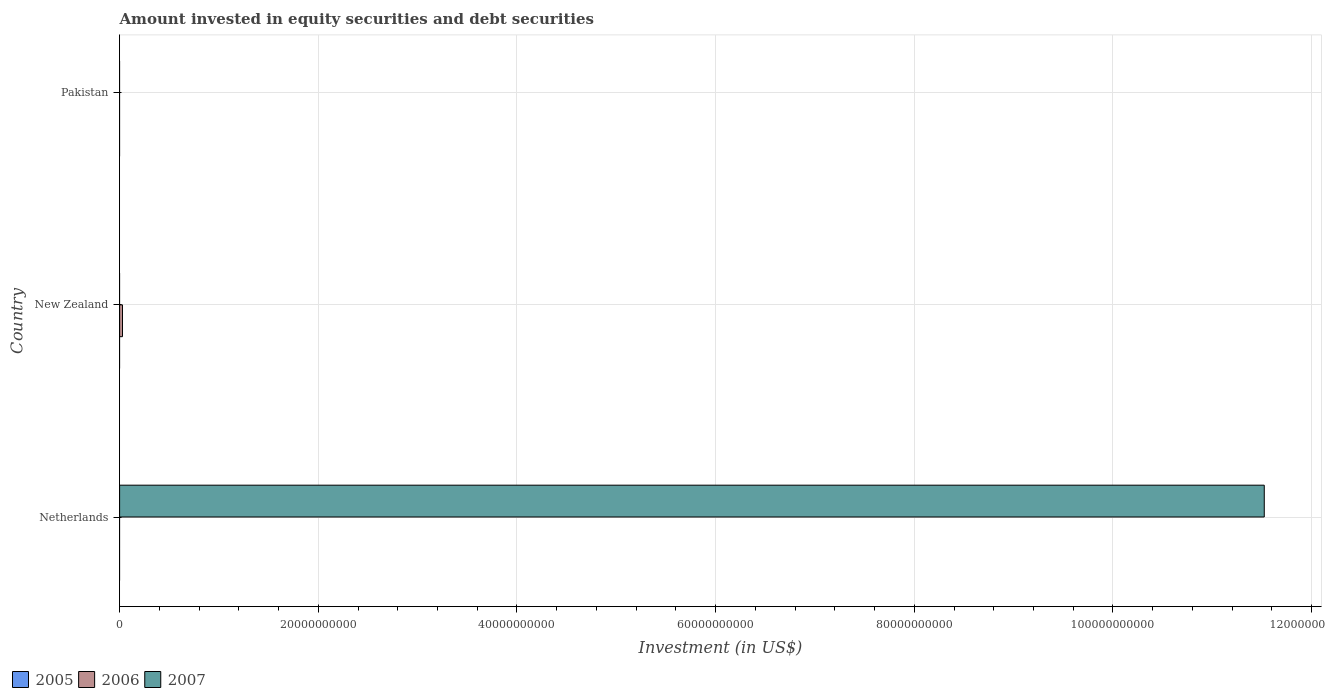Are the number of bars on each tick of the Y-axis equal?
Give a very brief answer. No. How many bars are there on the 2nd tick from the top?
Provide a succinct answer. 1. How many bars are there on the 3rd tick from the bottom?
Your answer should be compact. 0. In how many cases, is the number of bars for a given country not equal to the number of legend labels?
Keep it short and to the point. 3. Across all countries, what is the maximum amount invested in equity securities and debt securities in 2007?
Your answer should be compact. 1.15e+11. Across all countries, what is the minimum amount invested in equity securities and debt securities in 2006?
Ensure brevity in your answer.  0. What is the total amount invested in equity securities and debt securities in 2007 in the graph?
Your response must be concise. 1.15e+11. What is the difference between the amount invested in equity securities and debt securities in 2007 in Netherlands and the amount invested in equity securities and debt securities in 2006 in Pakistan?
Your answer should be compact. 1.15e+11. What is the average amount invested in equity securities and debt securities in 2007 per country?
Give a very brief answer. 3.84e+1. What is the difference between the highest and the lowest amount invested in equity securities and debt securities in 2006?
Your answer should be very brief. 2.91e+08. Is it the case that in every country, the sum of the amount invested in equity securities and debt securities in 2006 and amount invested in equity securities and debt securities in 2005 is greater than the amount invested in equity securities and debt securities in 2007?
Give a very brief answer. No. What is the difference between two consecutive major ticks on the X-axis?
Your response must be concise. 2.00e+1. Are the values on the major ticks of X-axis written in scientific E-notation?
Your answer should be compact. No. Does the graph contain any zero values?
Your answer should be very brief. Yes. Does the graph contain grids?
Provide a short and direct response. Yes. How many legend labels are there?
Provide a short and direct response. 3. What is the title of the graph?
Your answer should be compact. Amount invested in equity securities and debt securities. What is the label or title of the X-axis?
Your response must be concise. Investment (in US$). What is the label or title of the Y-axis?
Provide a succinct answer. Country. What is the Investment (in US$) in 2005 in Netherlands?
Your answer should be compact. 0. What is the Investment (in US$) in 2006 in Netherlands?
Provide a short and direct response. 0. What is the Investment (in US$) of 2007 in Netherlands?
Your answer should be very brief. 1.15e+11. What is the Investment (in US$) in 2006 in New Zealand?
Make the answer very short. 2.91e+08. What is the Investment (in US$) of 2005 in Pakistan?
Keep it short and to the point. 0. Across all countries, what is the maximum Investment (in US$) in 2006?
Your answer should be compact. 2.91e+08. Across all countries, what is the maximum Investment (in US$) in 2007?
Your response must be concise. 1.15e+11. What is the total Investment (in US$) of 2006 in the graph?
Offer a terse response. 2.91e+08. What is the total Investment (in US$) of 2007 in the graph?
Your response must be concise. 1.15e+11. What is the average Investment (in US$) of 2005 per country?
Your answer should be compact. 0. What is the average Investment (in US$) of 2006 per country?
Your response must be concise. 9.69e+07. What is the average Investment (in US$) in 2007 per country?
Your answer should be very brief. 3.84e+1. What is the difference between the highest and the lowest Investment (in US$) of 2006?
Keep it short and to the point. 2.91e+08. What is the difference between the highest and the lowest Investment (in US$) in 2007?
Provide a succinct answer. 1.15e+11. 